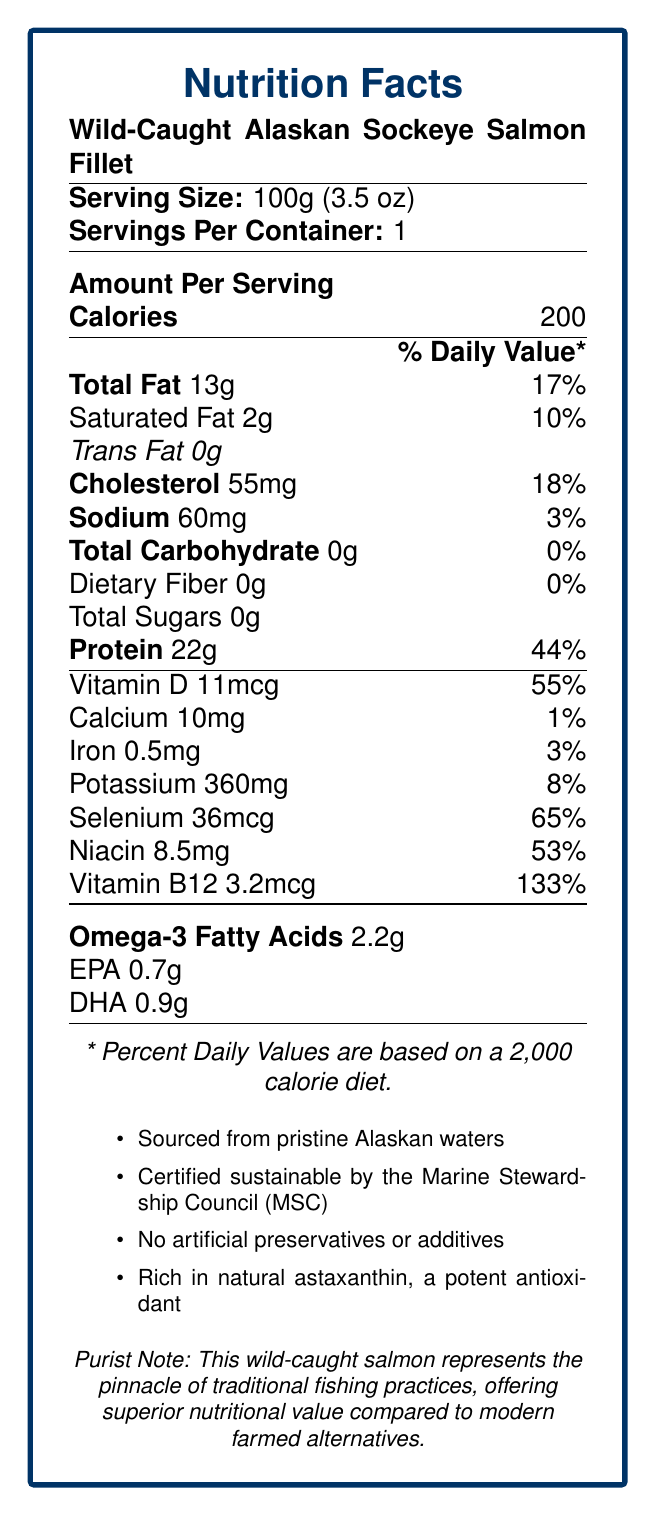what is the serving size of the Wild-Caught Alaskan Sockeye Salmon Fillet? The serving size is listed at the top of the nutrition facts label as "Serving Size: 100g (3.5 oz)."
Answer: 100g (3.5 oz) How many calories are there per serving? The calories per serving are shown under "Amount Per Serving" in the nutrition facts label.
Answer: 200 What percentage of the daily value does the protein content of the salmon fillet represent? The document mentions "Protein 22g," and next to it, "44%", indicating the percentage of the daily value.
Answer: 44% Is there any trans fat in this salmon fillet? The document explicitly states "Trans Fat 0g," indicating there is no trans fat in the salmon fillet.
Answer: No How much sodium is in the salmon fillet? The sodium content is listed under the nutrition facts as "Sodium 60mg."
Answer: 60mg What is the percentage of daily value for Vitamin B12? The percentage of daily value for Vitamin B12 is listed as 133% on the nutrition facts label.
Answer: 133% Does the document claim this product has artificial preservatives or additives? The additional information explicitly claims "No artificial preservatives or additives."
Answer: No How much Omega-3 fatty acids are present per serving? The Omega-3 fatty acids content is listed as 2.2g in the document.
Answer: 2.2g Is the salmon fillet a good source of Vitamin D? The document lists Vitamin D as 11mcg, which represents 55% of the daily value, indicating it is a good source.
Answer: Yes Does the nutrition label mention the marine stewardship certification? The document states that it is "Certified sustainable by the Marine Stewardship Council (MSC)."
Answer: Yes Which of the following nutrients has the highest daily value percentage in this salmon fillet? A. Calcium B. Iron C. Selenium D. Vitamin B12 Vitamin B12 has the highest daily value percentage at 133%, compared to Selenium (65%), Iron (3%), and Calcium (1%).
Answer: D. Vitamin B12 What are the unique selling points highlighted in the additional information section? A. Sourced from Alaskan waters B. Contains no artificial additives C. Rich in antioxidants D. Both B and C The additional information mentions the salmon is "No artificial preservatives or additives" and "Rich in natural astaxanthin, a potent antioxidant."
Answer: D. Both B and C Is the total carbohydrate content of this product greater than 0 grams? The document lists "Total Carbohydrate 0g," indicating there are no carbohydrates in the salmon fillet.
Answer: No Summarize the key nutritional benefits of consuming Wild-Caught Alaskan Sockeye Salmon Fillet. The fillet's nutritional highlights include protein, essential vitamins, and Omega-3 fatty acids. The document also notes its sustainable sourcing and absence of artificial additives.
Answer: The Wild-Caught Alaskan Sockeye Salmon Fillet provides high protein (22g, 44% DV), significant amounts of Vitamin D (11mcg, 55% DV), and Vitamin B12 (3.2mcg, 133% DV). It also contains beneficial Omega-3 fatty acids (2.2g) and is certified sustainable with no artificial additives. How does the total fat content compare in terms of daily value percentage between saturated and unsaturated fats? The label provides total fat (13g) and saturated fat (2g) daily values but does not specifically break down the remaining unsaturated fat content.
Answer: Not enough information Is the salmon fillet sourced from a sustainable environment? The document mentions that it is "Certified sustainable by the Marine Stewardship Council (MSC)."
Answer: Yes What is the purist's perspective on this salmon fillet according to the document? The purist note specifically mentions the use of traditional fishing practices and highlights the authentic flavor and superior nutritional value.
Answer: It offers superior nutritional value compared to modern farmed alternatives due to traditional fishing practices and an authentic flavor profile. 